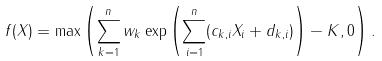Convert formula to latex. <formula><loc_0><loc_0><loc_500><loc_500>f ( X ) = \max \left ( \sum _ { k = 1 } ^ { n } w _ { k } \exp \left ( \sum _ { i = 1 } ^ { n } ( c _ { k , i } X _ { i } + d _ { k , i } ) \right ) - K , 0 \right ) .</formula> 